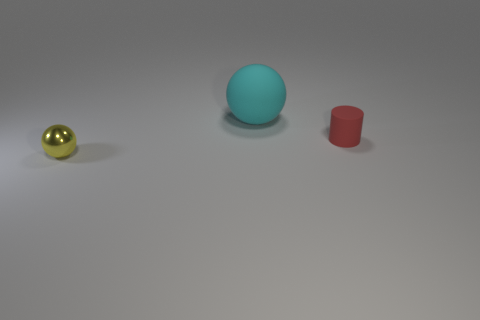There is a thing that is to the left of the small red cylinder and to the right of the yellow object; what is its color?
Your response must be concise. Cyan. Are there any other things that have the same size as the matte sphere?
Provide a succinct answer. No. Are there more rubber things in front of the matte ball than matte spheres to the right of the rubber cylinder?
Make the answer very short. Yes. There is a thing in front of the red rubber thing; does it have the same size as the large rubber object?
Your answer should be very brief. No. There is a matte thing that is right of the big cyan ball that is behind the tiny red rubber cylinder; how many large rubber spheres are on the left side of it?
Keep it short and to the point. 1. What is the size of the thing that is to the right of the small yellow metallic ball and to the left of the small cylinder?
Provide a short and direct response. Large. What number of other things are the same shape as the small red matte object?
Offer a very short reply. 0. What number of cyan objects are to the left of the small red matte object?
Keep it short and to the point. 1. Is the number of tiny red cylinders that are on the right side of the large matte thing less than the number of things that are right of the small yellow metal sphere?
Make the answer very short. Yes. The tiny object that is on the right side of the object that is on the left side of the ball behind the tiny shiny object is what shape?
Provide a short and direct response. Cylinder. 